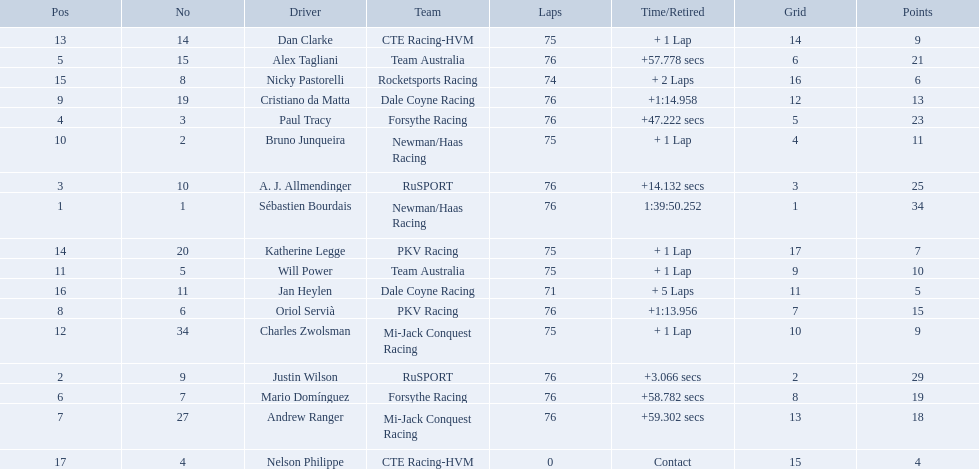Is there a driver named charles zwolsman? Charles Zwolsman. How many points did he acquire? 9. Were there any other entries that got the same number of points? 9. Who did that entry belong to? Dan Clarke. 